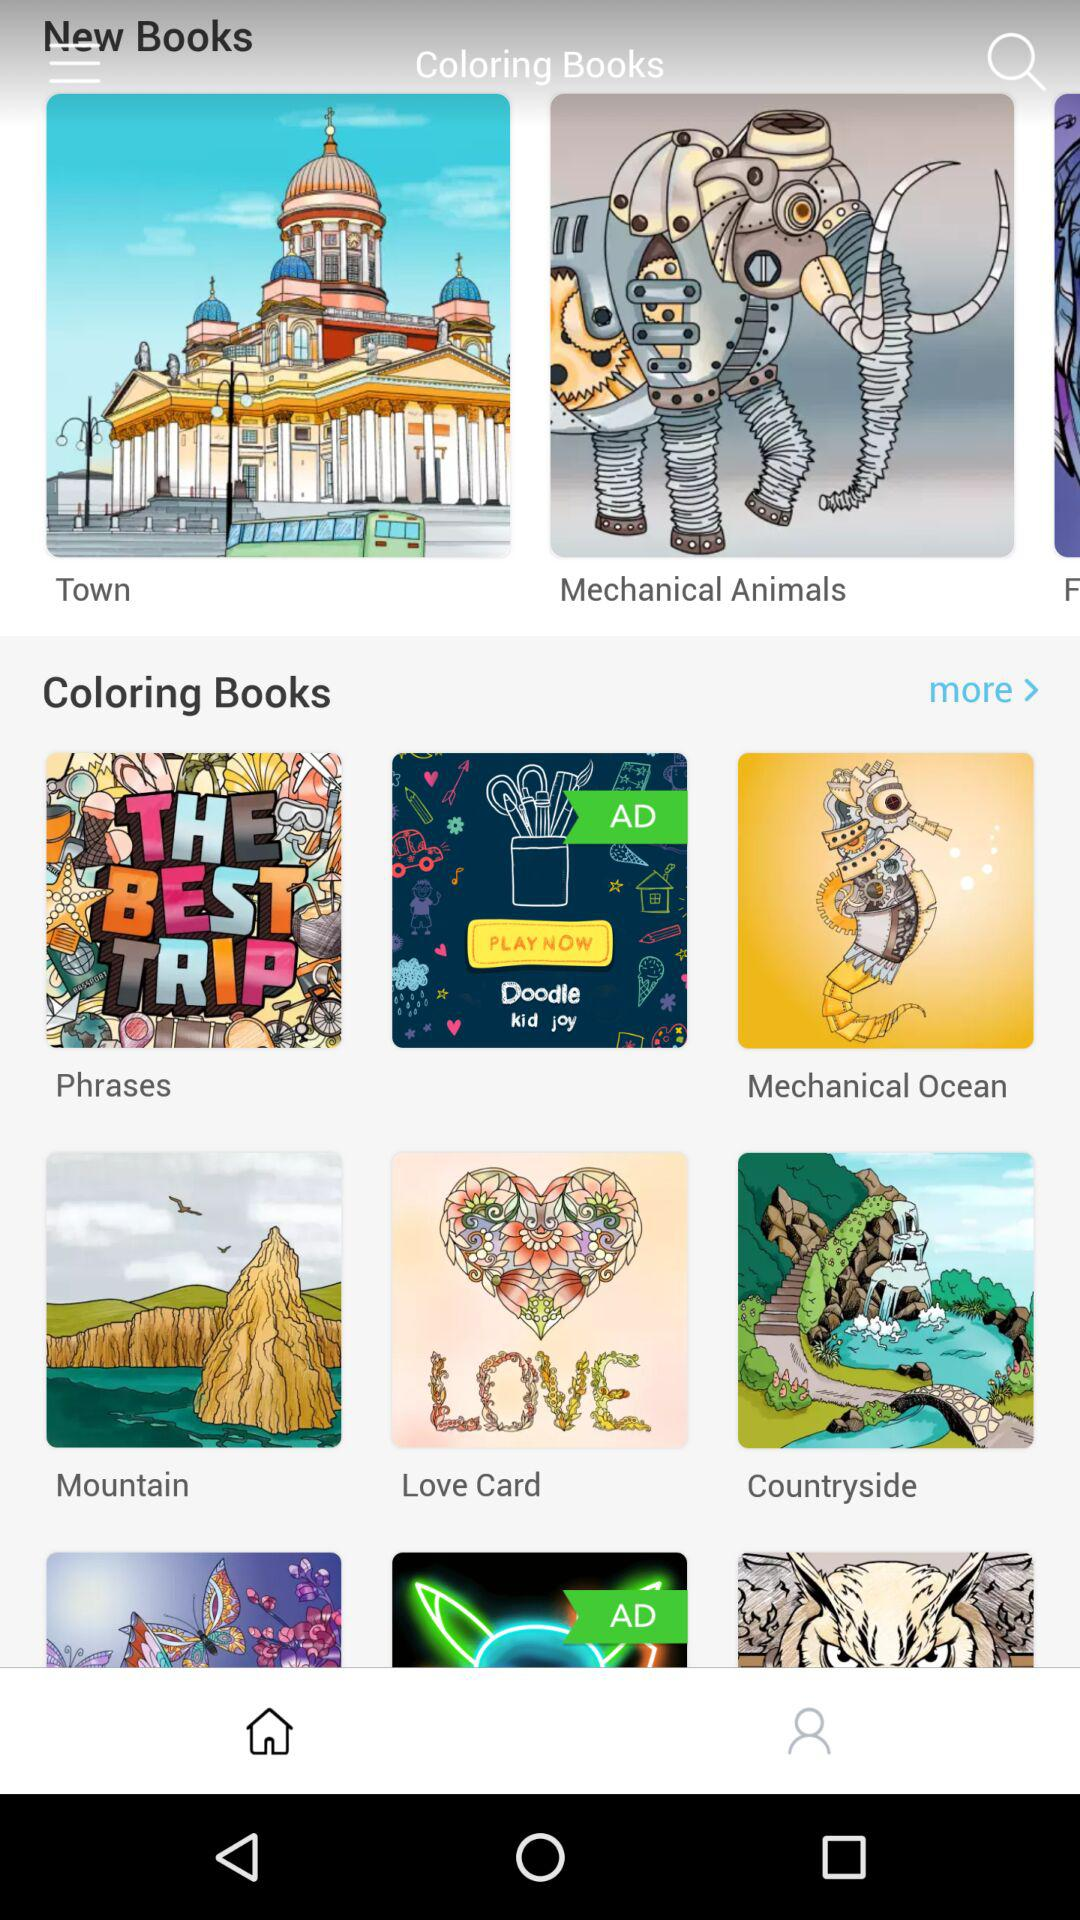What are the names of the coloring books? The names of the coloring books are "Phrases", "Mechanical Ocean", "Mountain", "Love Card" and "Countryside". 